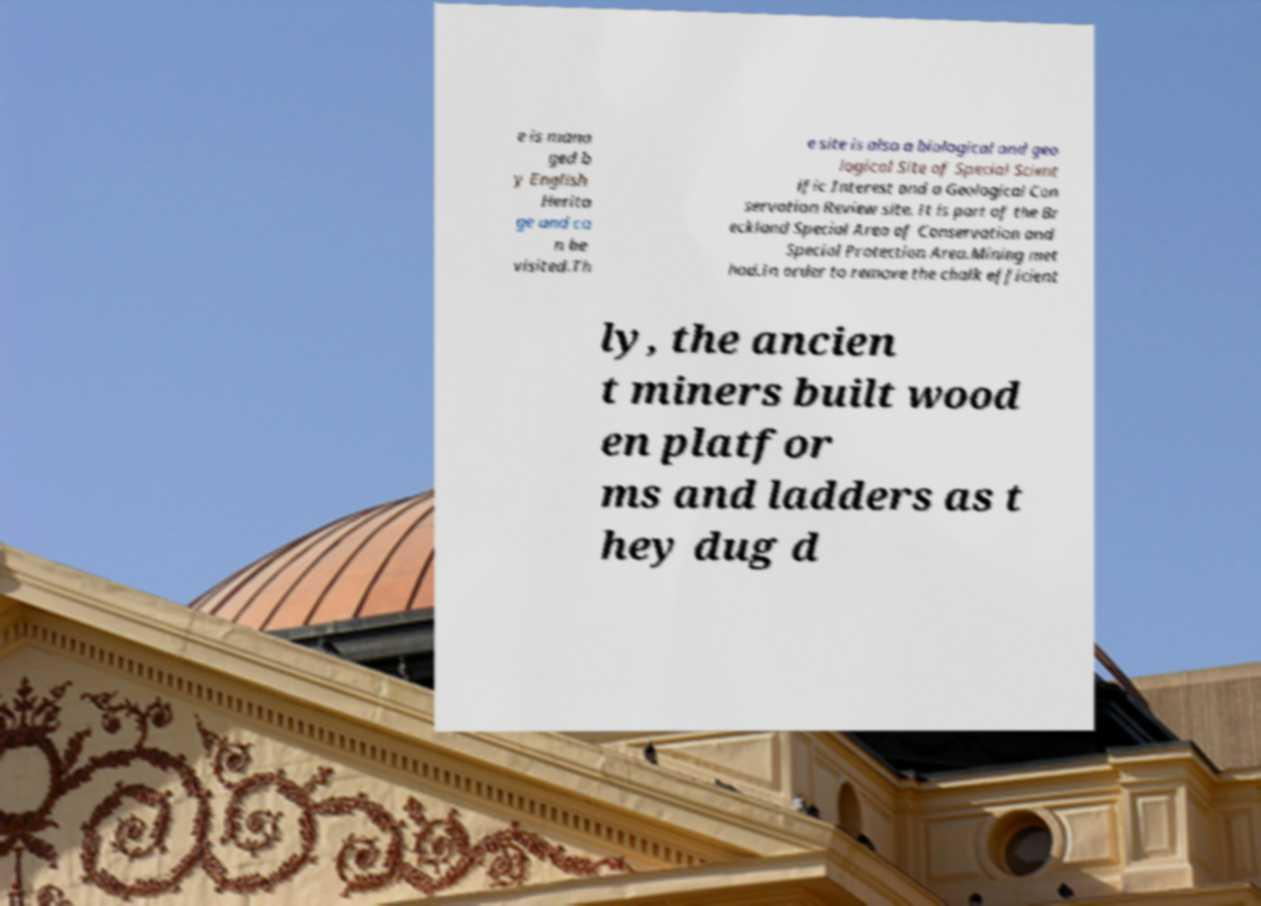There's text embedded in this image that I need extracted. Can you transcribe it verbatim? e is mana ged b y English Herita ge and ca n be visited.Th e site is also a biological and geo logical Site of Special Scient ific Interest and a Geological Con servation Review site. It is part of the Br eckland Special Area of Conservation and Special Protection Area.Mining met hod.In order to remove the chalk efficient ly, the ancien t miners built wood en platfor ms and ladders as t hey dug d 